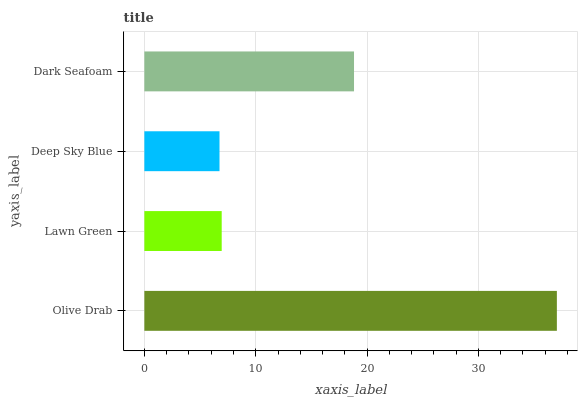Is Deep Sky Blue the minimum?
Answer yes or no. Yes. Is Olive Drab the maximum?
Answer yes or no. Yes. Is Lawn Green the minimum?
Answer yes or no. No. Is Lawn Green the maximum?
Answer yes or no. No. Is Olive Drab greater than Lawn Green?
Answer yes or no. Yes. Is Lawn Green less than Olive Drab?
Answer yes or no. Yes. Is Lawn Green greater than Olive Drab?
Answer yes or no. No. Is Olive Drab less than Lawn Green?
Answer yes or no. No. Is Dark Seafoam the high median?
Answer yes or no. Yes. Is Lawn Green the low median?
Answer yes or no. Yes. Is Deep Sky Blue the high median?
Answer yes or no. No. Is Dark Seafoam the low median?
Answer yes or no. No. 